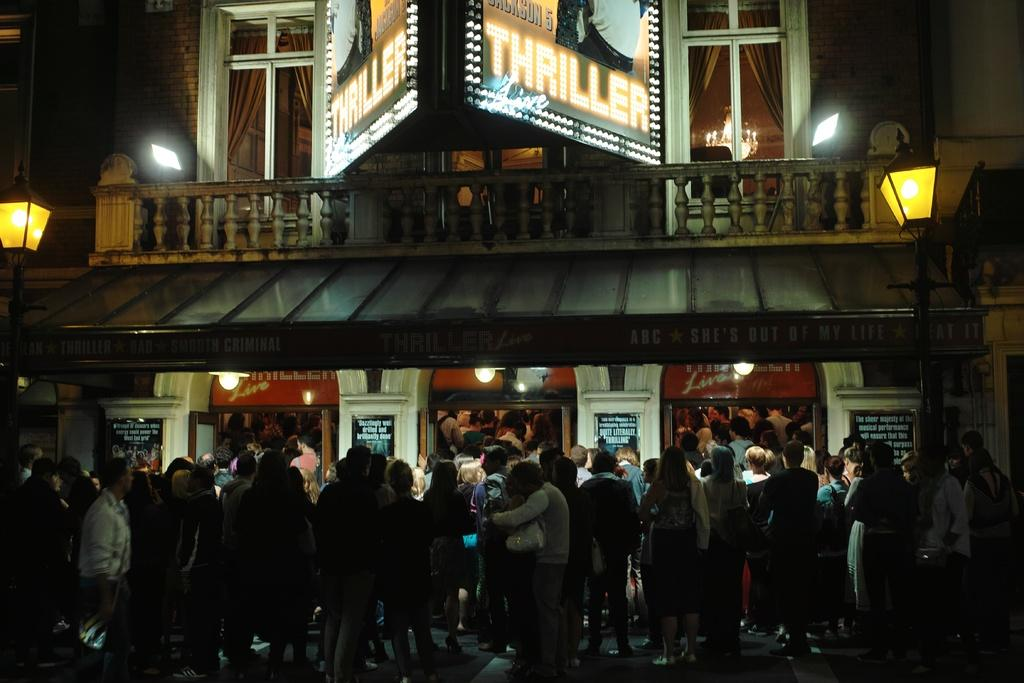<image>
Describe the image concisely. A crowd is gathered outside a small theater that is showing Jackson 5 Thriller Live. 